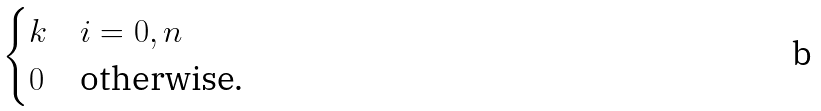Convert formula to latex. <formula><loc_0><loc_0><loc_500><loc_500>\begin{cases} k & i = 0 , n \\ 0 & \text {otherwise.} \end{cases}</formula> 